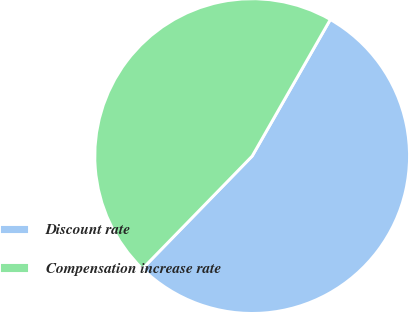Convert chart. <chart><loc_0><loc_0><loc_500><loc_500><pie_chart><fcel>Discount rate<fcel>Compensation increase rate<nl><fcel>54.02%<fcel>45.98%<nl></chart> 